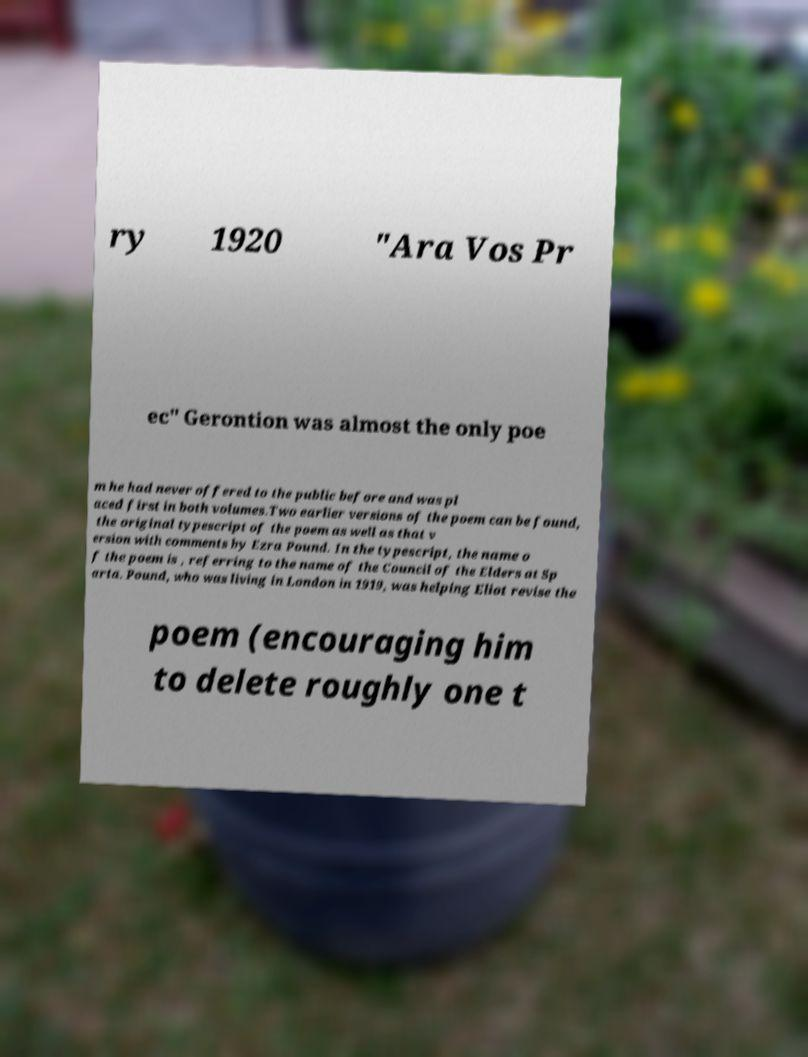Could you assist in decoding the text presented in this image and type it out clearly? ry 1920 "Ara Vos Pr ec" Gerontion was almost the only poe m he had never offered to the public before and was pl aced first in both volumes.Two earlier versions of the poem can be found, the original typescript of the poem as well as that v ersion with comments by Ezra Pound. In the typescript, the name o f the poem is , referring to the name of the Council of the Elders at Sp arta. Pound, who was living in London in 1919, was helping Eliot revise the poem (encouraging him to delete roughly one t 